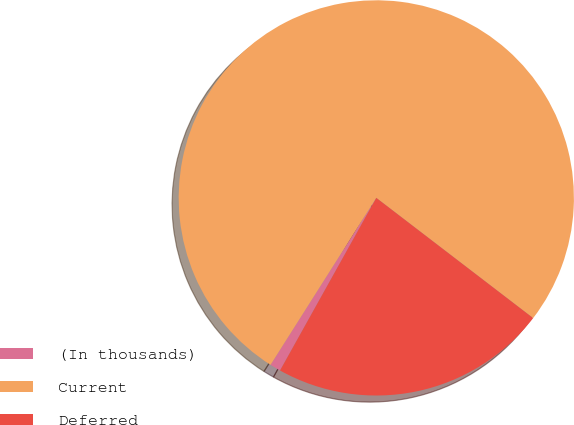Convert chart to OTSL. <chart><loc_0><loc_0><loc_500><loc_500><pie_chart><fcel>(In thousands)<fcel>Current<fcel>Deferred<nl><fcel>0.89%<fcel>76.43%<fcel>22.69%<nl></chart> 